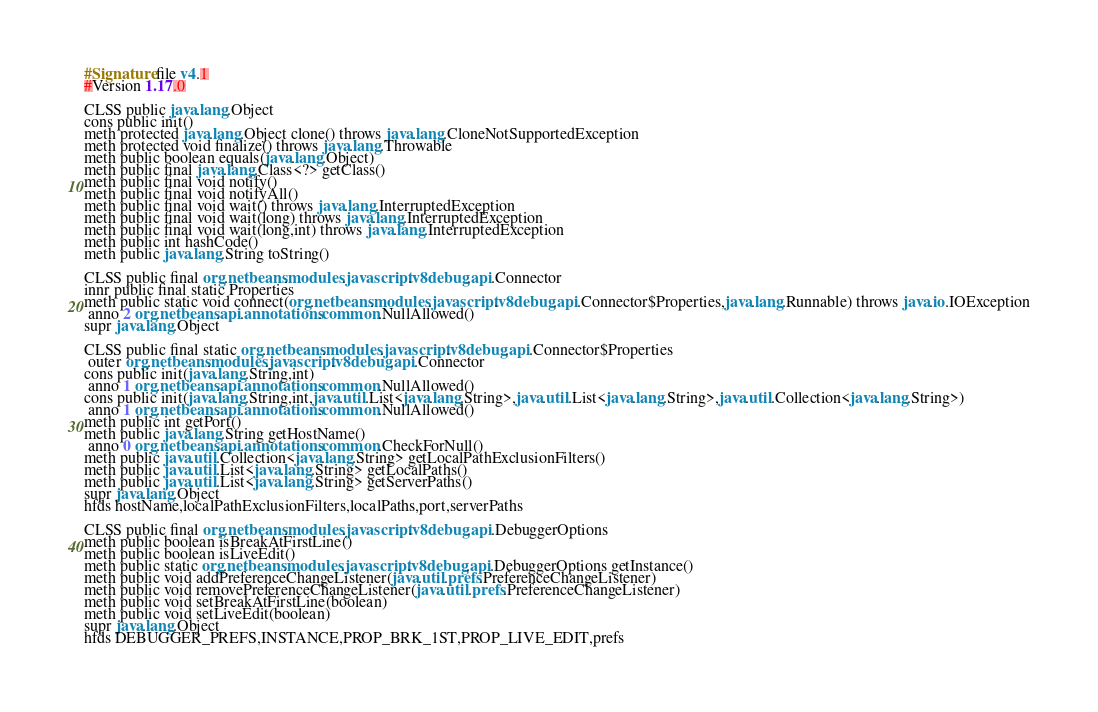Convert code to text. <code><loc_0><loc_0><loc_500><loc_500><_SML_>#Signature file v4.1
#Version 1.17.0

CLSS public java.lang.Object
cons public init()
meth protected java.lang.Object clone() throws java.lang.CloneNotSupportedException
meth protected void finalize() throws java.lang.Throwable
meth public boolean equals(java.lang.Object)
meth public final java.lang.Class<?> getClass()
meth public final void notify()
meth public final void notifyAll()
meth public final void wait() throws java.lang.InterruptedException
meth public final void wait(long) throws java.lang.InterruptedException
meth public final void wait(long,int) throws java.lang.InterruptedException
meth public int hashCode()
meth public java.lang.String toString()

CLSS public final org.netbeans.modules.javascript.v8debug.api.Connector
innr public final static Properties
meth public static void connect(org.netbeans.modules.javascript.v8debug.api.Connector$Properties,java.lang.Runnable) throws java.io.IOException
 anno 2 org.netbeans.api.annotations.common.NullAllowed()
supr java.lang.Object

CLSS public final static org.netbeans.modules.javascript.v8debug.api.Connector$Properties
 outer org.netbeans.modules.javascript.v8debug.api.Connector
cons public init(java.lang.String,int)
 anno 1 org.netbeans.api.annotations.common.NullAllowed()
cons public init(java.lang.String,int,java.util.List<java.lang.String>,java.util.List<java.lang.String>,java.util.Collection<java.lang.String>)
 anno 1 org.netbeans.api.annotations.common.NullAllowed()
meth public int getPort()
meth public java.lang.String getHostName()
 anno 0 org.netbeans.api.annotations.common.CheckForNull()
meth public java.util.Collection<java.lang.String> getLocalPathExclusionFilters()
meth public java.util.List<java.lang.String> getLocalPaths()
meth public java.util.List<java.lang.String> getServerPaths()
supr java.lang.Object
hfds hostName,localPathExclusionFilters,localPaths,port,serverPaths

CLSS public final org.netbeans.modules.javascript.v8debug.api.DebuggerOptions
meth public boolean isBreakAtFirstLine()
meth public boolean isLiveEdit()
meth public static org.netbeans.modules.javascript.v8debug.api.DebuggerOptions getInstance()
meth public void addPreferenceChangeListener(java.util.prefs.PreferenceChangeListener)
meth public void removePreferenceChangeListener(java.util.prefs.PreferenceChangeListener)
meth public void setBreakAtFirstLine(boolean)
meth public void setLiveEdit(boolean)
supr java.lang.Object
hfds DEBUGGER_PREFS,INSTANCE,PROP_BRK_1ST,PROP_LIVE_EDIT,prefs

</code> 